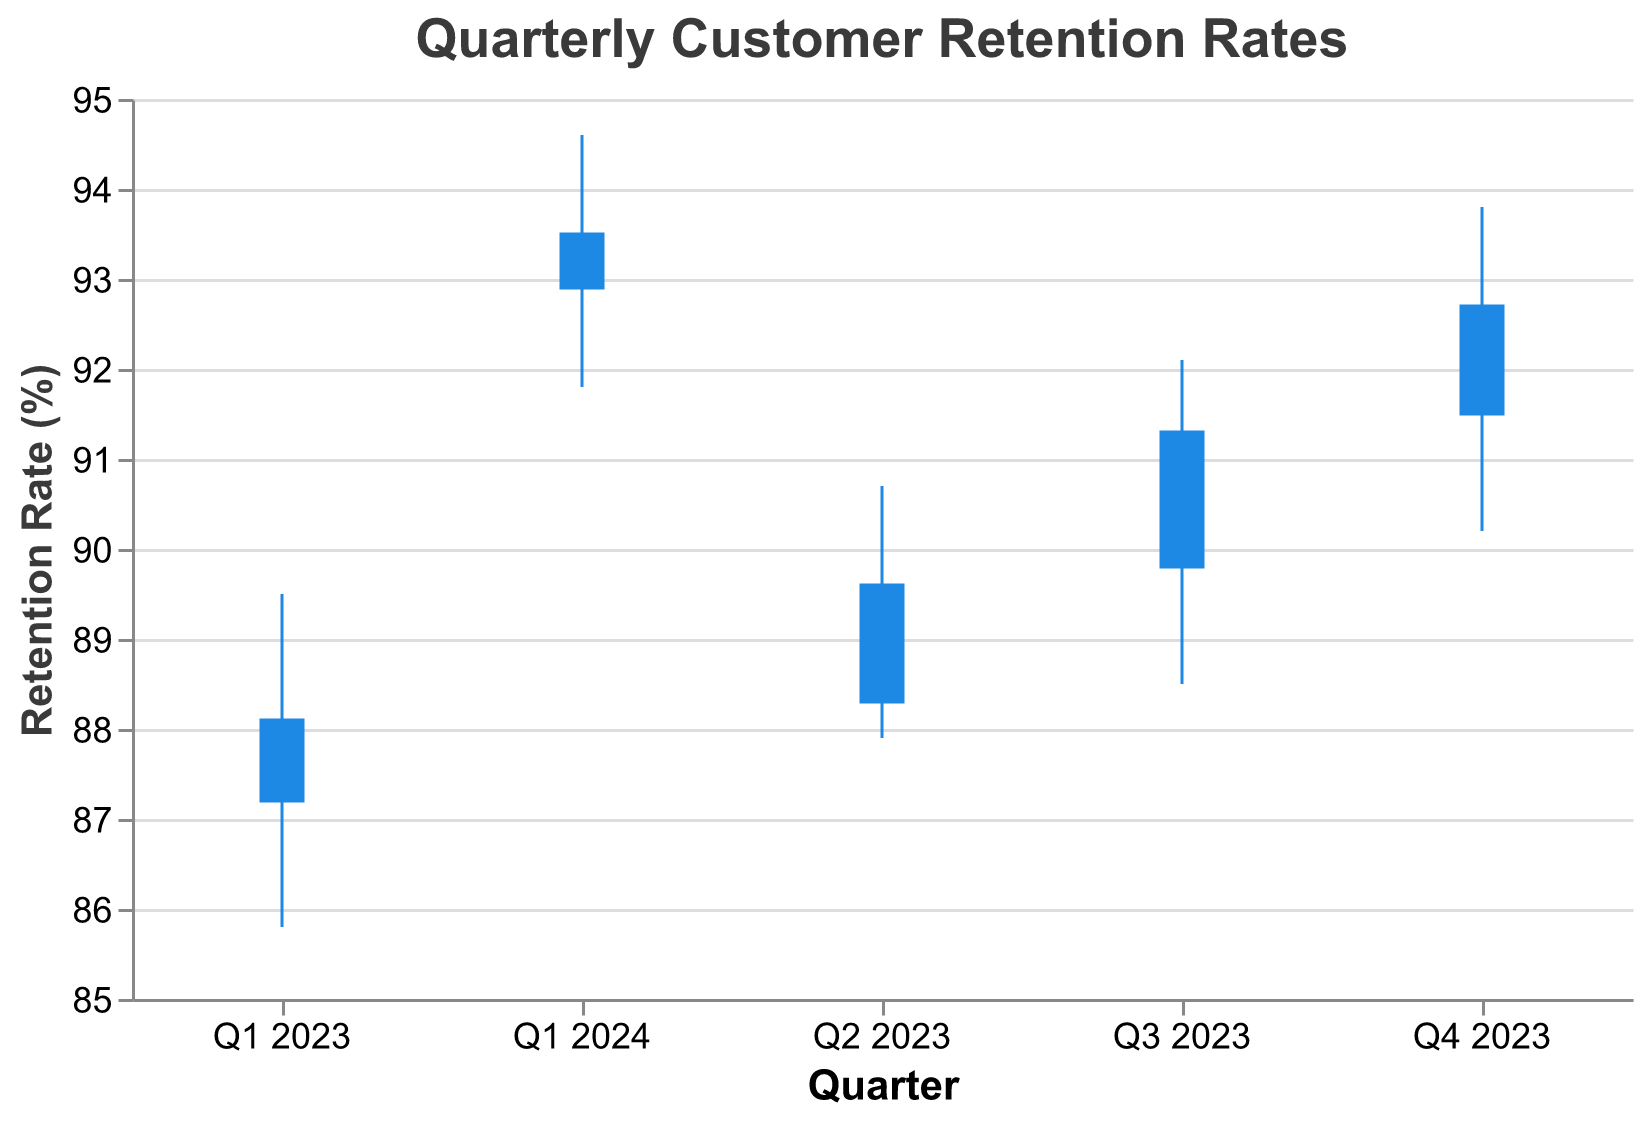What is the title of the figure? The title is displayed at the top of the figure and helps to understand the context of the data presented. It says "Quarterly Customer Retention Rates".
Answer: Quarterly Customer Retention Rates Which quarter has the highest final retention rate? By looking at the final retention rates on the y-axis for each quarter, Q1 2024 has the highest final rate at 93.5%.
Answer: Q1 2024 What was the lowest retention rate in Q3 2023? Observe the lowest point of the vertical line corresponding to Q3 2023 on the y-axis, which shows 88.5%.
Answer: 88.5% What is the difference between the highest and lowest retention rates in Q4 2023? Subtracting the lowest retention rate of Q4 2023 (90.2%) from the highest retention rate (93.8%) gives the difference. 93.8% - 90.2% = 3.6%.
Answer: 3.6% Which quarter experienced the smallest range between its highest and lowest retention rates? By visually comparing the lengths of the vertical lines for each quarter, Q1 2024 had the smallest range, as the difference between its highest (94.6%) and lowest (91.8%) retention rates is 2.8%.
Answer: Q1 2024 How does the final retention rate in Q1 2023 compare to the initial retention rate in Q2 2023? Comparing the data, the final retention rate in Q1 2023 is 88.1%, and the initial retention rate in Q2 2023 is 88.3%. The final rate of Q1 2023 is 0.2% lower than the initial rate of Q2 2023.
Answer: Q1 2023's final is lower What is the average final retention rate over the five quarters? Adding the final retention rates of all five quarters (88.1 + 89.6 + 91.3 + 92.7 + 93.5) and dividing by 5 gives the average: (88.1 + 89.6 + 91.3 + 92.7 + 93.5) / 5 = 91.04%.
Answer: 91.04% In which quarter was the improvement from initial to final retention rate the greatest? The change is calculated as Final - Initial for each quarter. The quarter with the largest positive change is Q3 2023 with a change of 91.3 - 89.8 = 1.5%.
Answer: Q3 2023 From Q1 2023 to Q1 2024, how much did the initial retention rate increase? Subtract the initial rate of Q1 2023 (87.2%) from that of Q1 2024 (92.9%). The increase is 92.9% - 87.2% = 5.7%.
Answer: 5.7% Which quarter saw the highest fluctuation within the retention rates? The highest fluctuation is seen in the quarter with the largest difference between highest and lowest retention rates. In Q4 2023, the difference is 93.8% - 90.2% = 3.6%, which is the largest among all quarters.
Answer: Q4 2023 